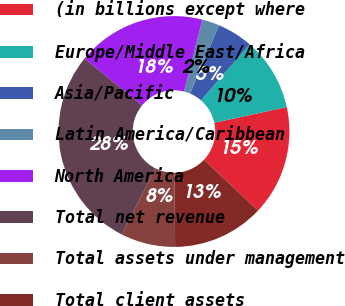<chart> <loc_0><loc_0><loc_500><loc_500><pie_chart><fcel>(in billions except where<fcel>Europe/Middle East/Africa<fcel>Asia/Pacific<fcel>Latin America/Caribbean<fcel>North America<fcel>Total net revenue<fcel>Total assets under management<fcel>Total client assets<nl><fcel>15.42%<fcel>10.22%<fcel>5.01%<fcel>2.41%<fcel>18.06%<fcel>28.44%<fcel>7.61%<fcel>12.82%<nl></chart> 